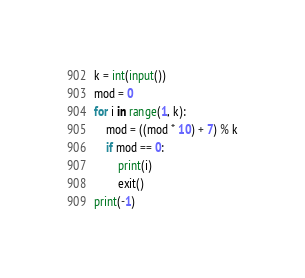Convert code to text. <code><loc_0><loc_0><loc_500><loc_500><_Python_>k = int(input())
mod = 0
for i in range(1, k):
    mod = ((mod * 10) + 7) % k
    if mod == 0:
        print(i)
        exit()
print(-1)</code> 